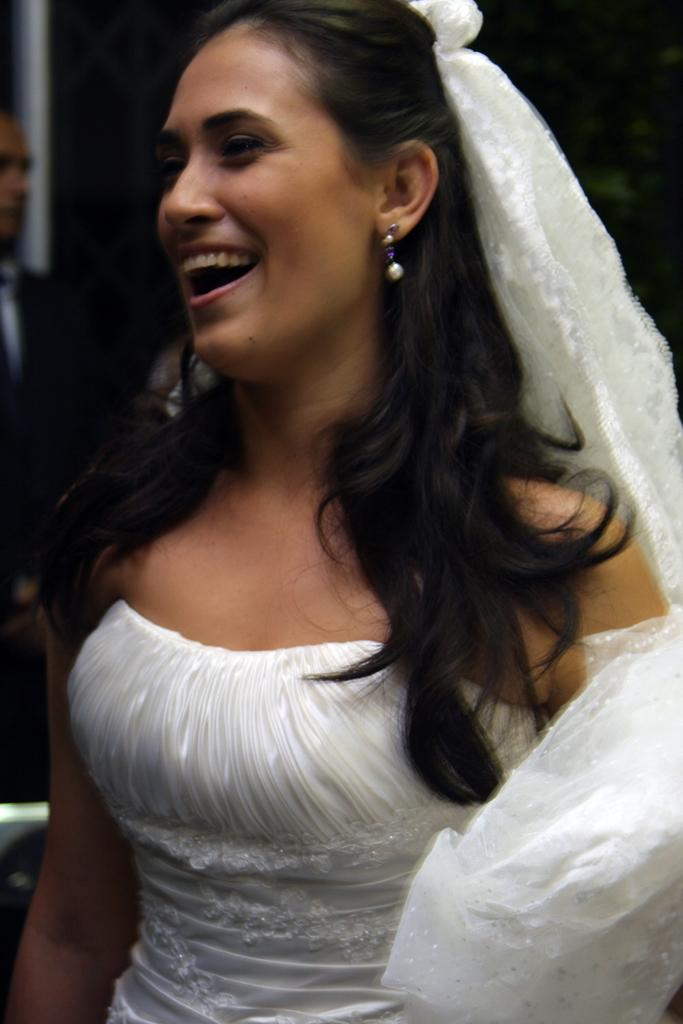Who is the main subject in the image? There is a lady in the image. What is the lady wearing? The lady is wearing a white dress. What is the lady doing in the image? The lady is standing. Can you describe the other person in the image? There is another person in the image, on the left side. What is the lady writing on the stage in the image? There is no stage or writing present in the image. The lady is simply standing in a location with another person nearby. 